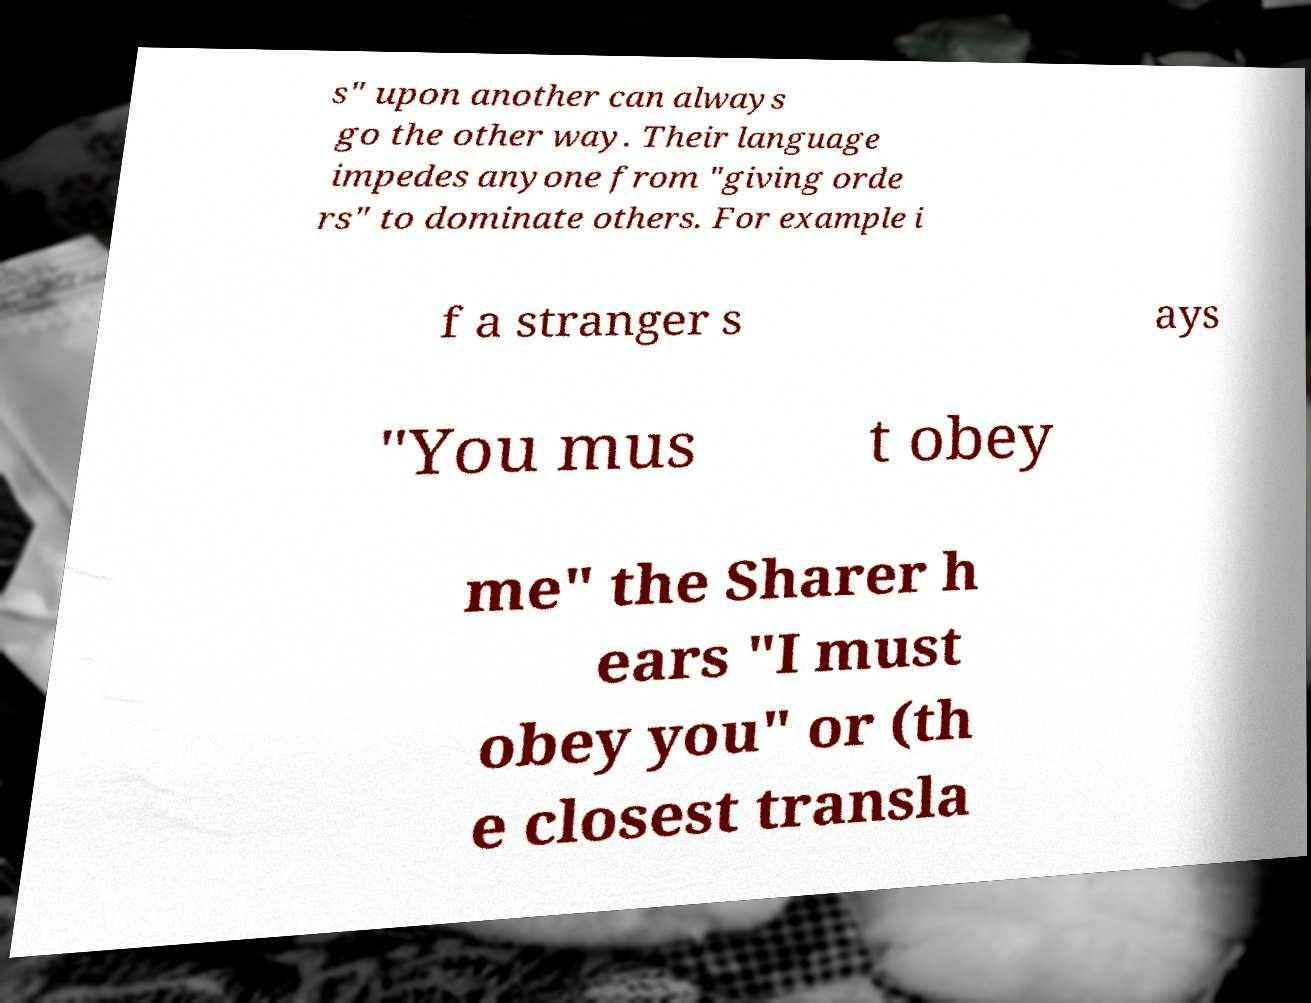Can you accurately transcribe the text from the provided image for me? s" upon another can always go the other way. Their language impedes anyone from "giving orde rs" to dominate others. For example i f a stranger s ays "You mus t obey me" the Sharer h ears "I must obey you" or (th e closest transla 